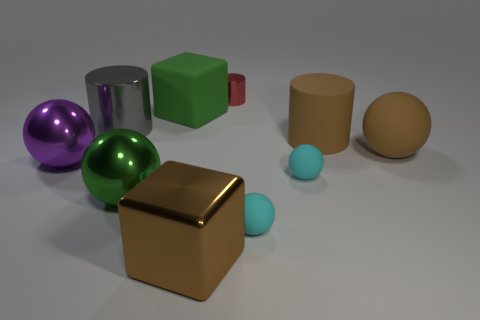Please compare the sizes of the objects. The objects vary in size, with the spheres being approximately the same size, which is medium in comparison to the other objects. The cubes and the cylinder are larger, while the egg-shaped object is similar in size to the spheres. The two cyan balls are the smallest objects present. 